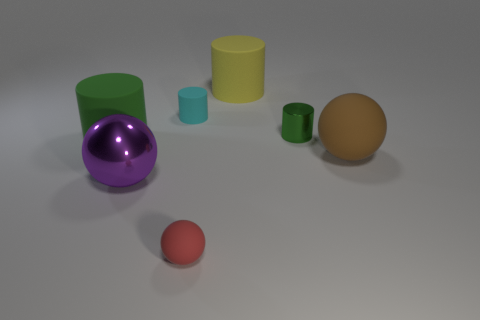Are there any other things that are the same size as the cyan matte cylinder?
Offer a terse response. Yes. Does the yellow matte thing behind the tiny red rubber ball have the same shape as the red thing?
Your response must be concise. No. Are there more metal cylinders that are to the right of the tiny metallic object than large red shiny things?
Your answer should be compact. No. What is the color of the tiny matte thing that is behind the sphere that is behind the purple ball?
Your answer should be compact. Cyan. What number of big blue blocks are there?
Provide a short and direct response. 0. What number of small cylinders are in front of the cyan matte object and on the left side of the small green metal cylinder?
Your answer should be compact. 0. Is there anything else that has the same shape as the large purple thing?
Keep it short and to the point. Yes. Do the tiny shiny cylinder and the small cylinder that is left of the small red matte object have the same color?
Offer a very short reply. No. The small rubber object in front of the large metallic ball has what shape?
Provide a succinct answer. Sphere. What number of other things are the same material as the purple object?
Provide a succinct answer. 1. 